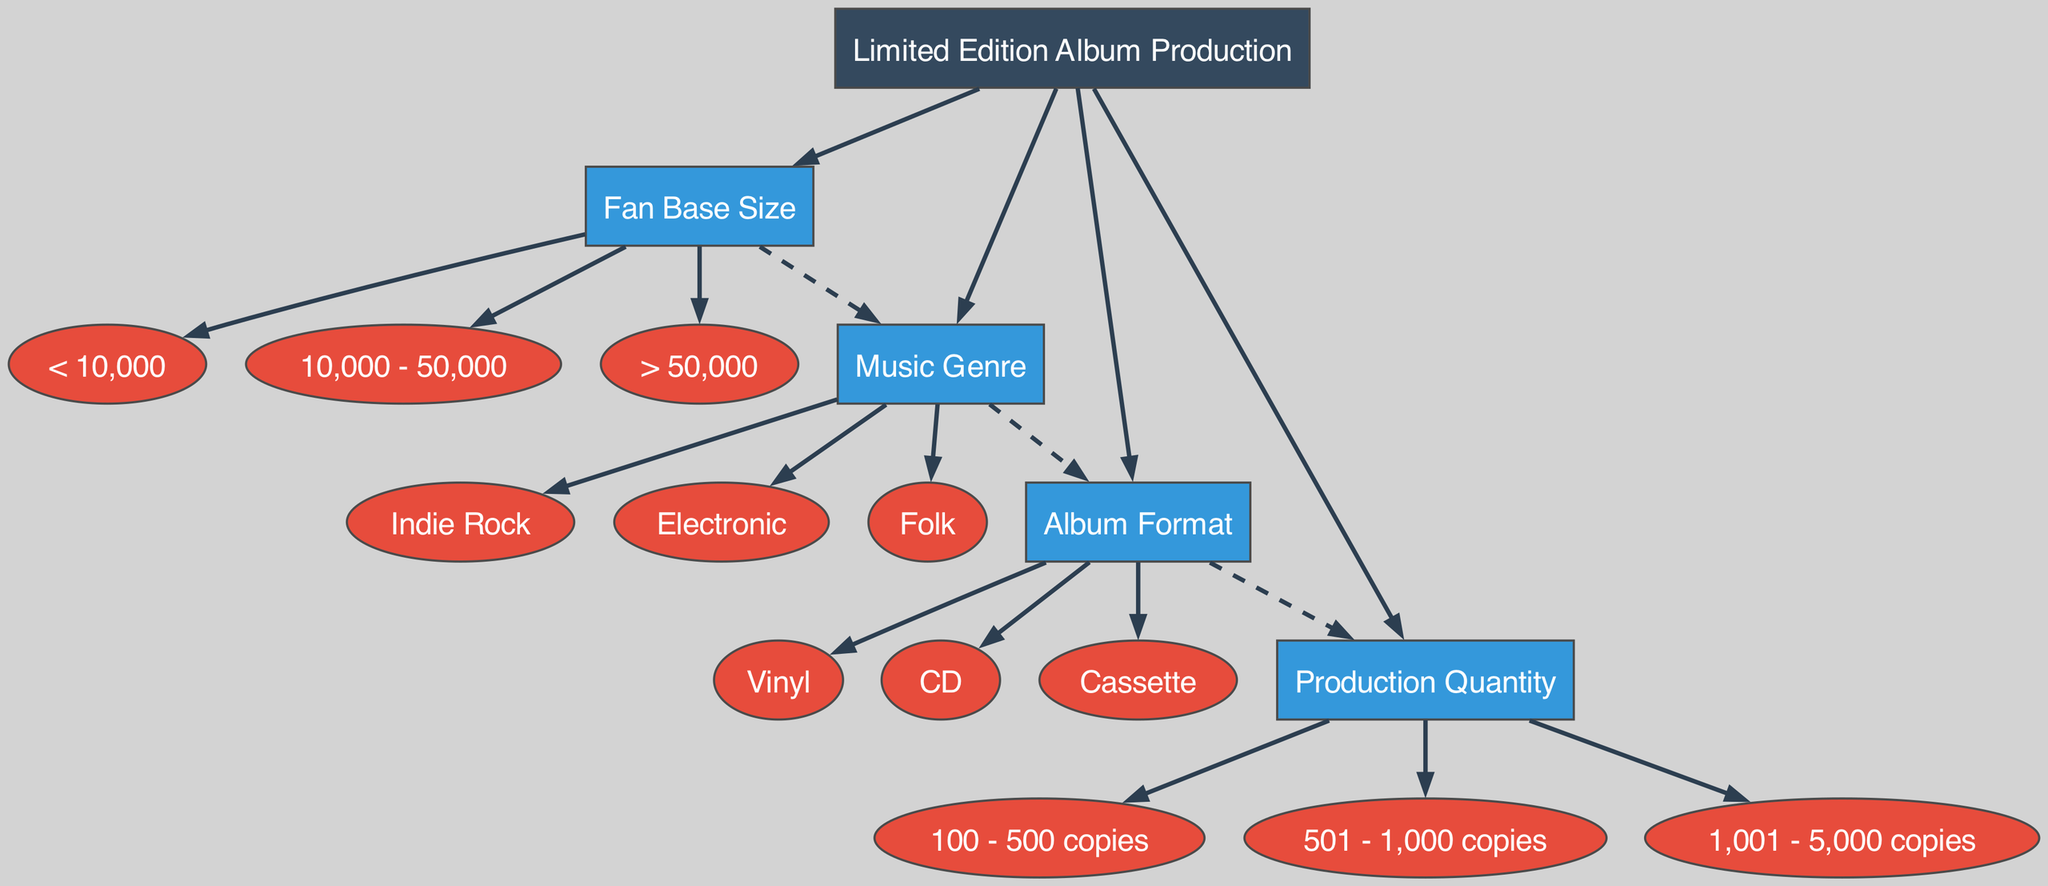What is the root node of the diagram? The root node is the starting point of the decision tree which represents the overall subject being analyzed, in this case, it is "Limited Edition Album Production."
Answer: Limited Edition Album Production How many main nodes are in the diagram? There are four main nodes besides the root node: Fan Base Size, Music Genre, Album Format, and Production Quantity.
Answer: 4 What is the production quantity if the album format is vinyl? To determine production quantity from the album format (vinyl), you follow the path from the root through the format node to production. The child nodes of production indicate varying quantities without specifics on format effects, hence it could imply any of the options based on decision clicks.
Answer: 100 - 500 copies, 501 - 1,000 copies, 1,001 - 5,000 copies What type of music genre leads to a medium production quantity? To find a music genre that could lead to a medium production quantity, you need to combine the music genre choice with a fan base size, but in isolation, option paths must further interrogate through a combination of fan base interpretations. It takes careful examination through the flow for complete clarity omitting full dependency chain details. However, a medium production quantity could arise from various genres typically favored by mid-sized fan bases.
Answer: Indie Rock, Electronic, Folk Which fan base size option leads to the genre node? The fan base size options are connected directly to the genre node, hence any choice of fan base leads to genre determination, it doesn't specify a single outcome but opens the pathway to genre clarity.
Answer: < 10,000, 10,000 - 50,000, > 50,000 Which children of the genre node are directly connected to the format node? The genre node has three children that lead directly to the format node: Indie Rock, Electronic, and Folk. Each child expands pathways influencing format decisions.
Answer: Indie Rock, Electronic, Folk What is the edge style between fan base size and music genre? The edge style denotes the nature of connection and in the case of the fan base size leading to music genre node, the connection is represented with a dashed edge signifying a relationship or influence.
Answer: Dashed Which music genre corresponds to the production quantity of 1,001 to 5,000 copies? The production quantity category of 1,001 to 5,000 copies can arise from any of the music genres, since the model does not restrict specific genre outcomes within production ranges without contextual clarifiers.
Answer: Indie Rock, Electronic, Folk 